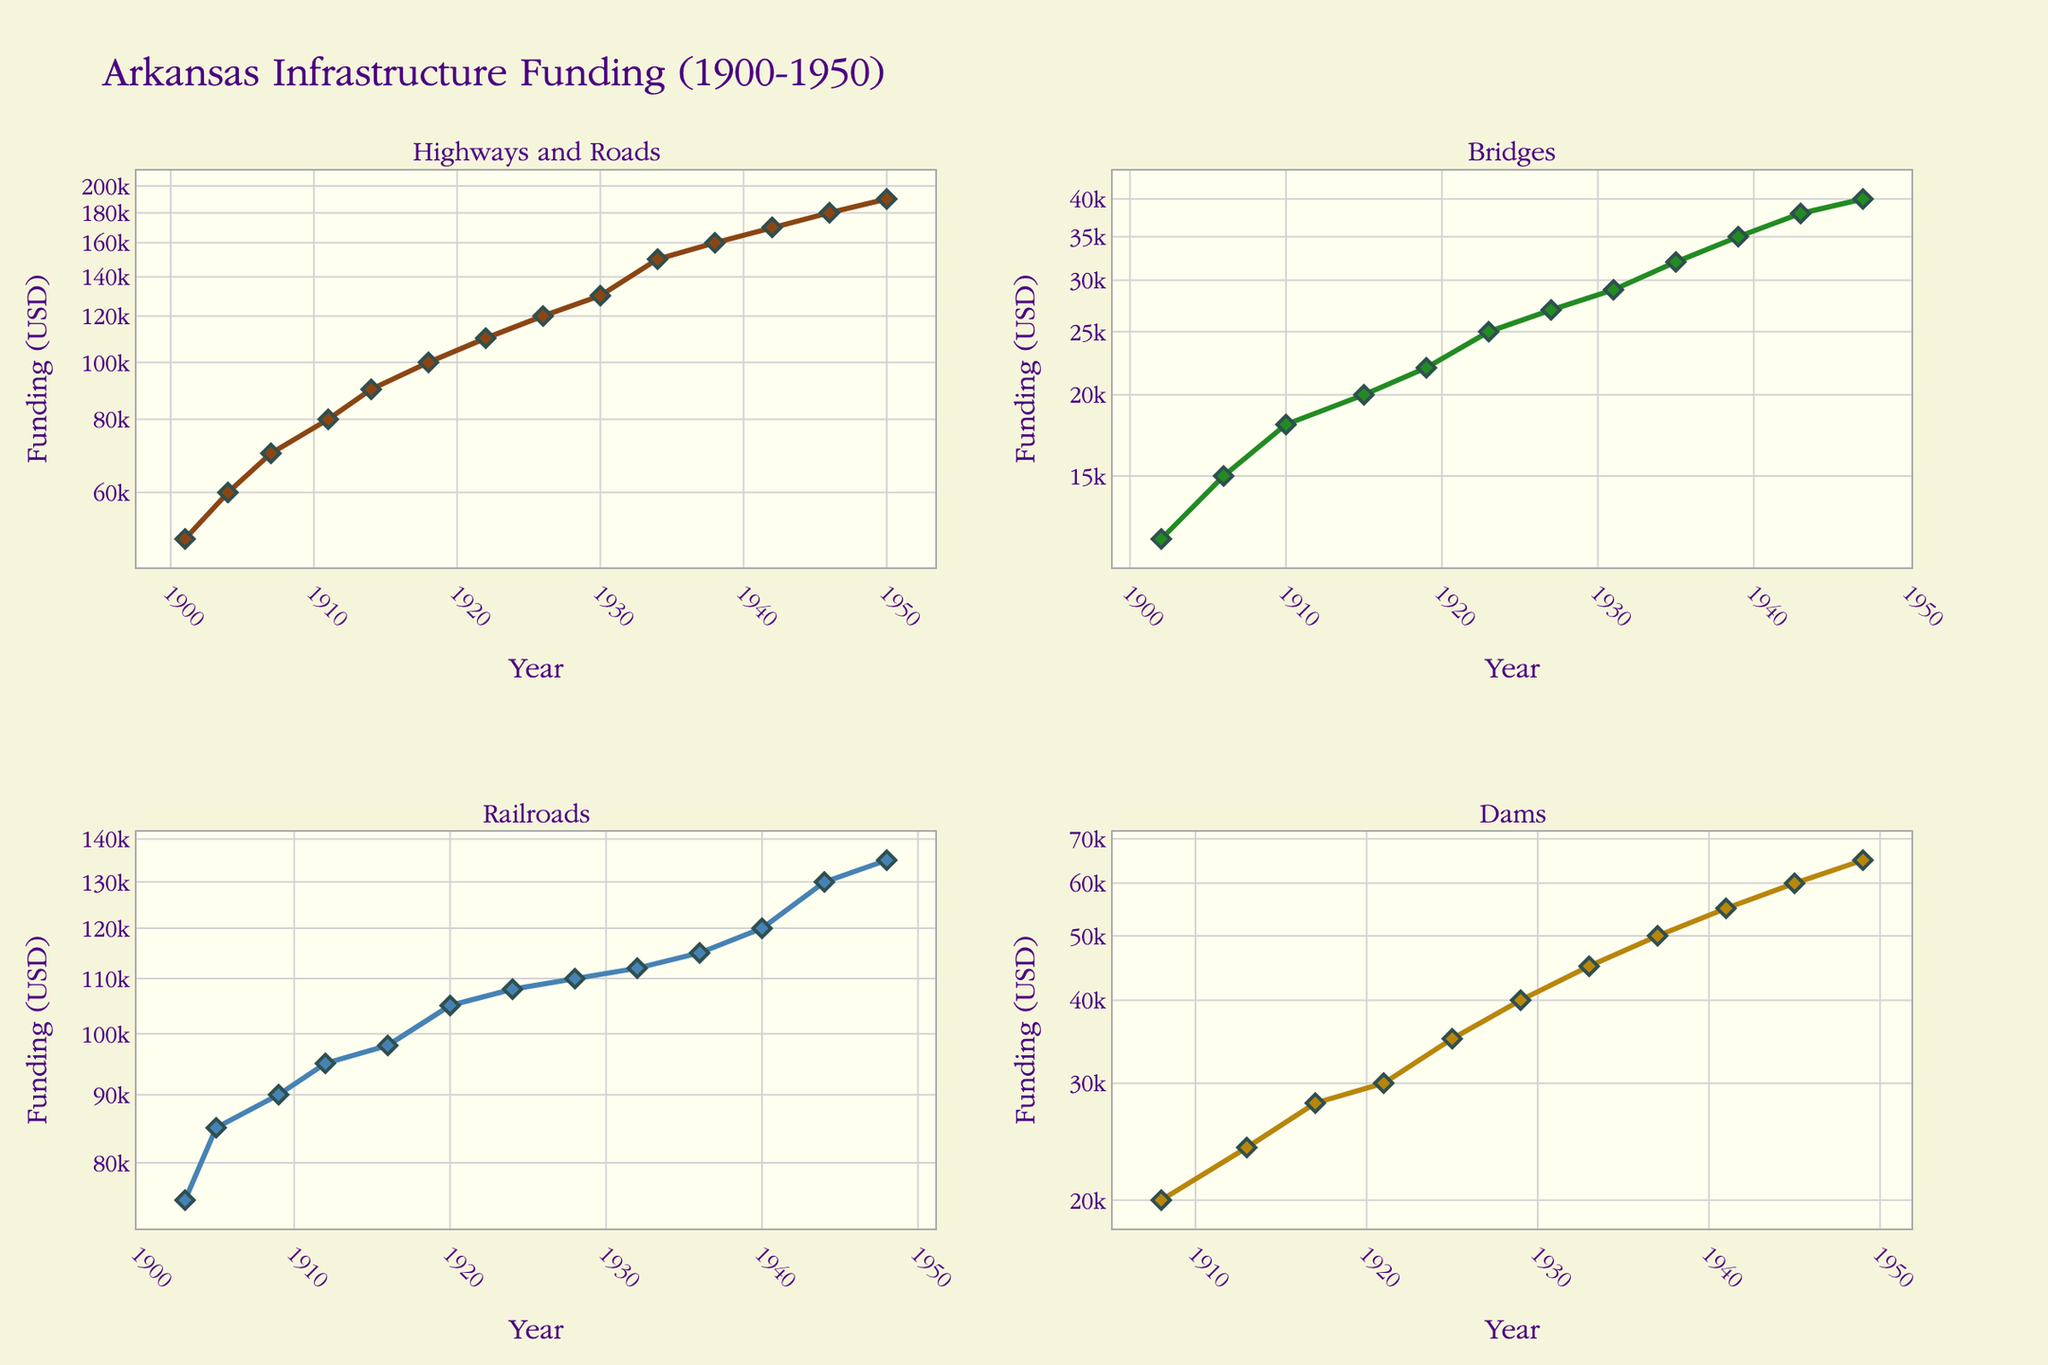What is the title of the figure? The title of the figure is displayed prominently at the top and usually summarizes the overall content of the figure. It helps the viewer quickly understand what the figure is about.
Answer: Arkansas Infrastructure Funding (1900-1950) Which project type had the highest funding in 1934? To find this information, locate the subplot for each project type and look at the funding for the year 1934. The highway and roads subplot shows a funding of $150,000, which is the highest among all project types for that year.
Answer: Highways and Roads How does the funding for Railroads in 1903 compare to the funding for Bridges in 1906? To compare these values, look at the subplots for Railroads and Bridges and find the funding amounts for the years 1903 and 1906 respectively. Railroads had $75,000 in 1903, while Bridges had $15,000 in 1906, so Railroads had significantly higher funding in that year.
Answer: Railroads had higher funding in 1903 What is the trend in funding for Dams from 1908 to 1950? The subplot for Dams shows the funding over the years. Observing this, it is evident that the funding for Dams increases steadily from $20,000 in 1908 to $65,000 in 1950.
Answer: Increasing trend Which project type saw the most variability in funding from 1900 to 1950? Compare the funding trends across all subplots. Highways and Roads show a wide range of funding from $50,000 to $190,000, which indicates it has the most variability in funding.
Answer: Highways and Roads In what year did Bridges receive $25,000 in funding? Look at the subplot for Bridges and find the year corresponding to the funding amount of $25,000. The year is 1923.
Answer: 1923 Which two consecutive years show the largest increase in funding for Railroads? Analyze the subplot for Railroads, noting changes between each year. The largest consecutive increase is from 1940 to 1941, where the funding jumps from $120,000 to $130,000.
Answer: 1940 to 1941 Did any project types have decreasing funding trends? Each subplot can be checked to see if there is any year-to-year decrease in funding. Railroads have consistent increases, while other projects such as Bridges, Dams, and Highways show occasional decreases but generally have increasing trends overall.
Answer: No project type had an overall decreasing trend What are the dominant colors used for each project type’s line? Identify the colors used in each subplot for the different project types. Highways and Roads use brown, Bridges use dark green, Railroads use blue, and Dams use golden colors.
Answer: Highways and Roads: Brown, Bridges: Dark Green, Railroads: Blue, Dams: Golden 